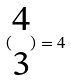<formula> <loc_0><loc_0><loc_500><loc_500>( \begin{matrix} 4 \\ 3 \end{matrix} ) = 4</formula> 